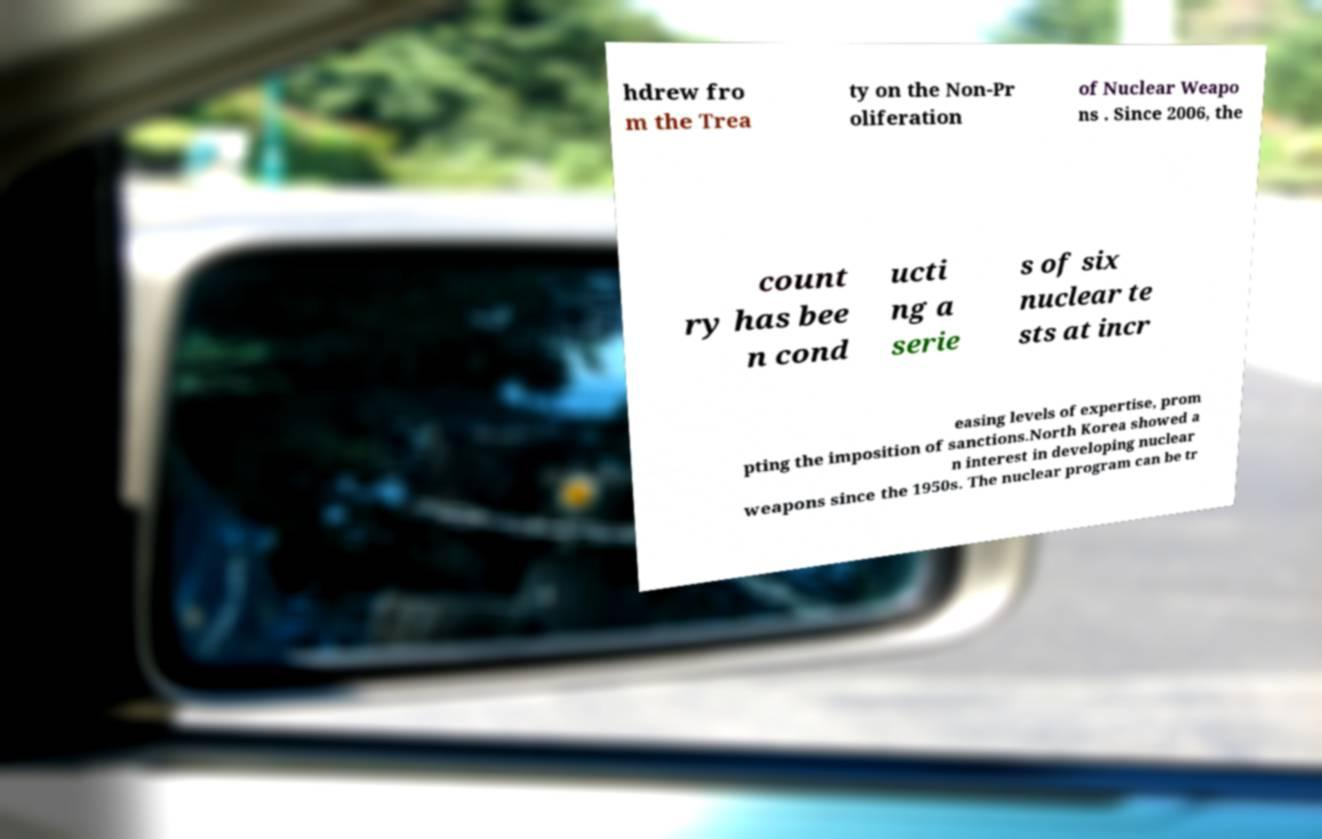Please identify and transcribe the text found in this image. hdrew fro m the Trea ty on the Non-Pr oliferation of Nuclear Weapo ns . Since 2006, the count ry has bee n cond ucti ng a serie s of six nuclear te sts at incr easing levels of expertise, prom pting the imposition of sanctions.North Korea showed a n interest in developing nuclear weapons since the 1950s. The nuclear program can be tr 